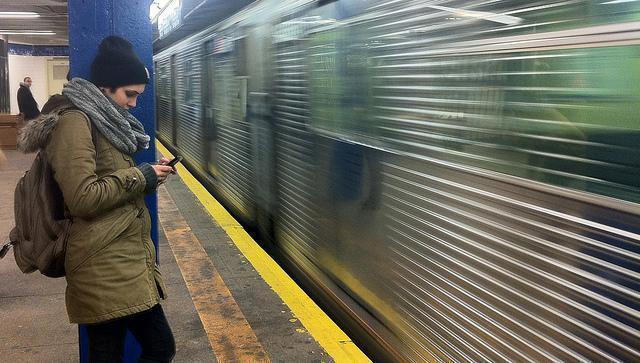What tells people where to stand for safety?
Pick the correct solution from the four options below to address the question.
Options: Garbage can, yellow line, train, blue column. Yellow line. 